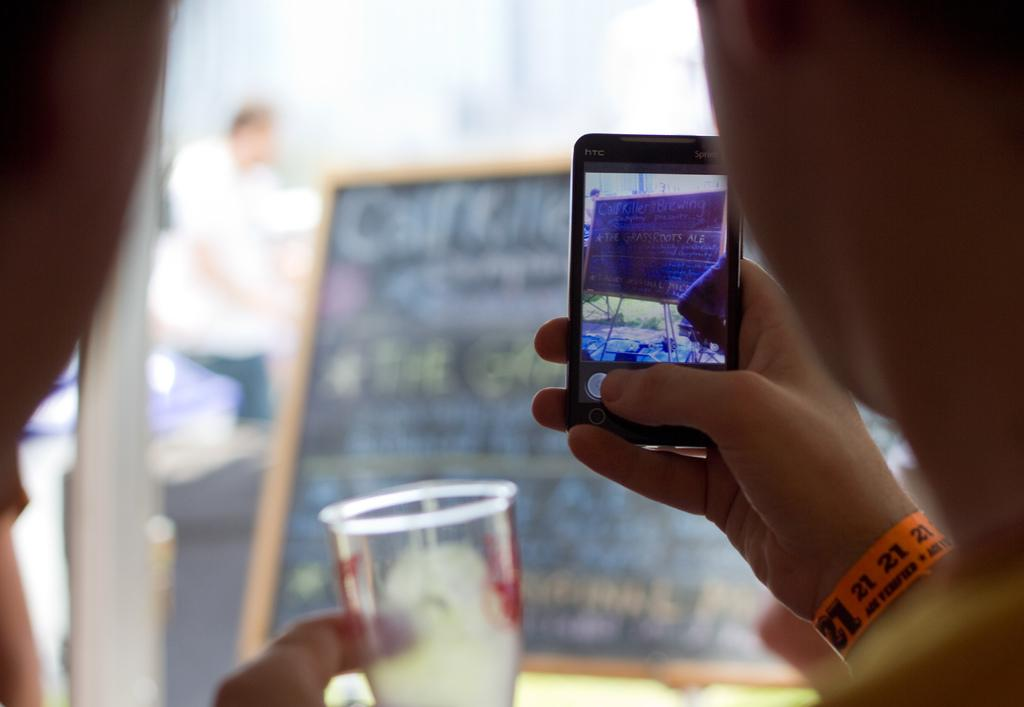<image>
Give a short and clear explanation of the subsequent image. A person holding a cell phone whilst wearing an orange wrist band with the number 21 on it 